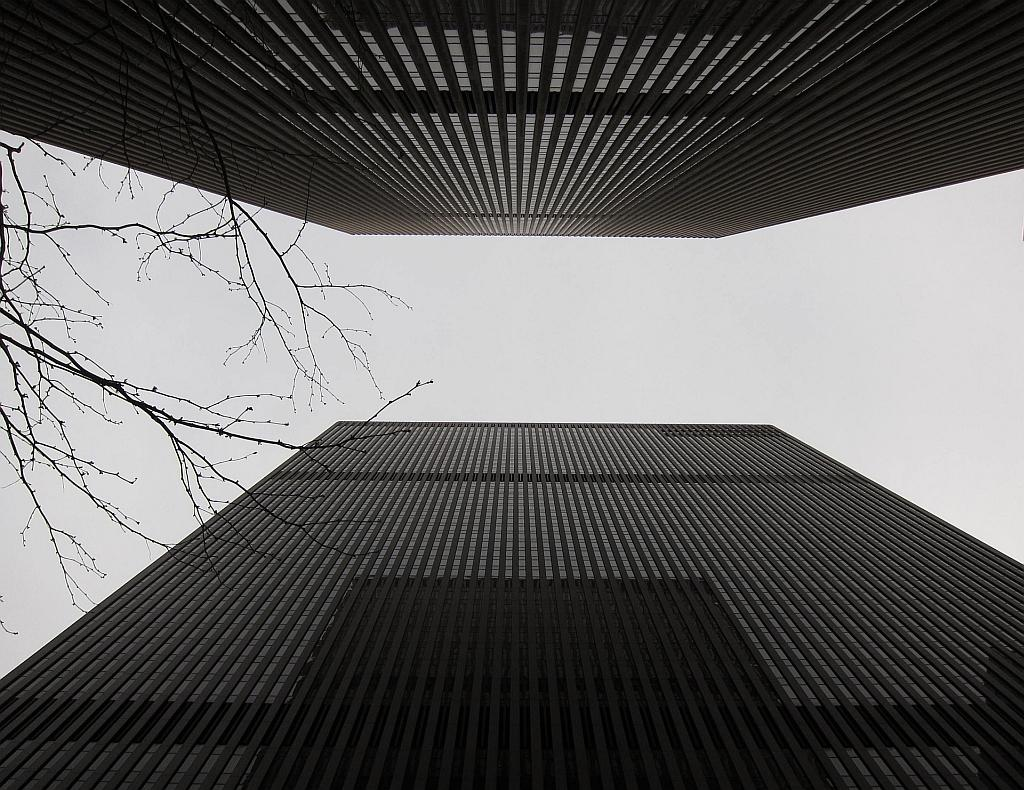What type of structures can be seen in the image? There are buildings in the image. What type of vegetation is present in the image? There is a tree in the image. What is visible in the background of the image? The sky is visible in the image. What type of paste is being used to hold the buildings together in the image? There is no paste present in the image, and the buildings are not being held together by any substance. 